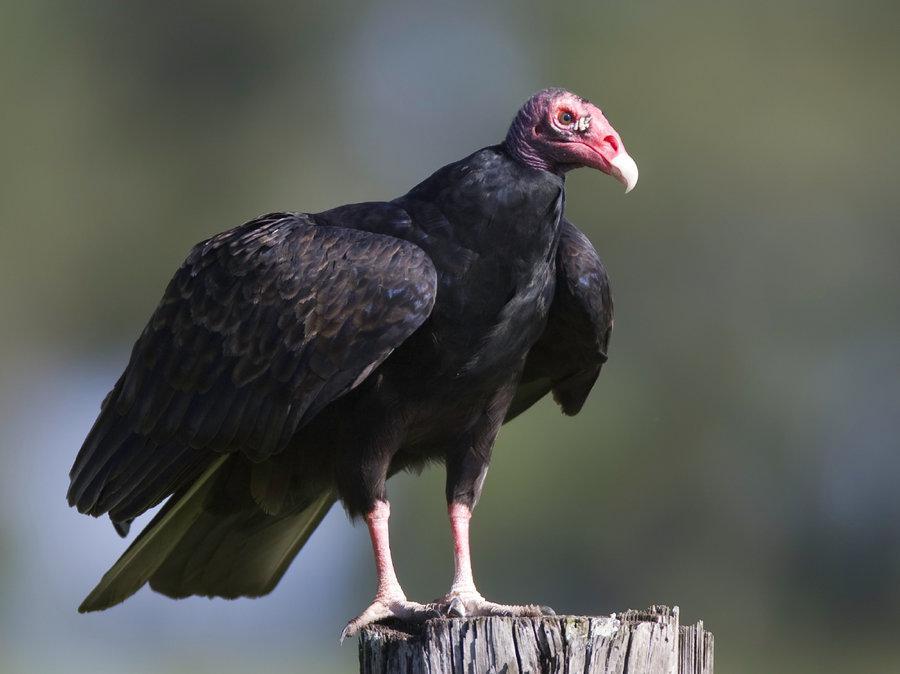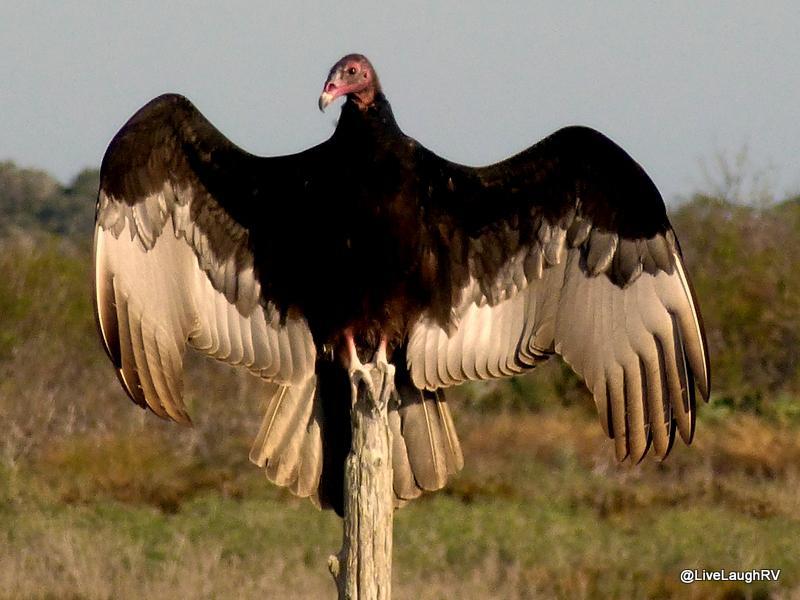The first image is the image on the left, the second image is the image on the right. Examine the images to the left and right. Is the description "The vulture on the left has a white neck and brown wings." accurate? Answer yes or no. No. 